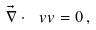Convert formula to latex. <formula><loc_0><loc_0><loc_500><loc_500>\vec { \nabla } \cdot \ v v = 0 \, ,</formula> 